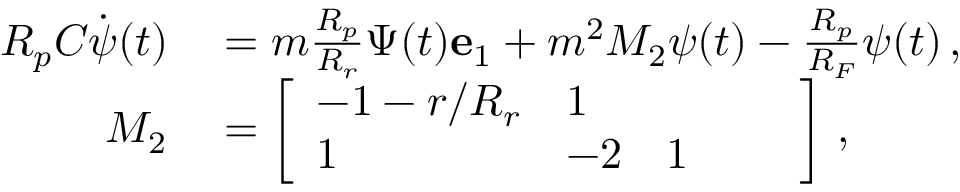<formula> <loc_0><loc_0><loc_500><loc_500>\begin{array} { r l } { R _ { p } C \dot { \psi } ( t ) } & = m \frac { R _ { p } } { R _ { r } } \Psi ( t ) e _ { 1 } + m ^ { 2 } M _ { 2 } \psi ( t ) - \frac { R _ { p } } { R _ { F } } \psi ( t ) \, , } \\ { M _ { 2 } } & = \left [ \begin{array} { l l l l l } { - 1 - r / R _ { r } } & { 1 } \\ { 1 } & { - 2 } & { 1 } \end{array} \right ] \, , } \end{array}</formula> 